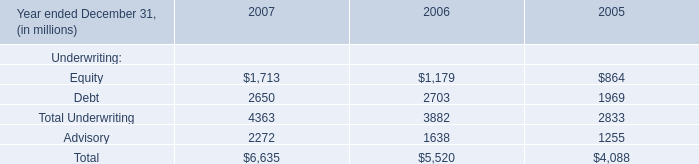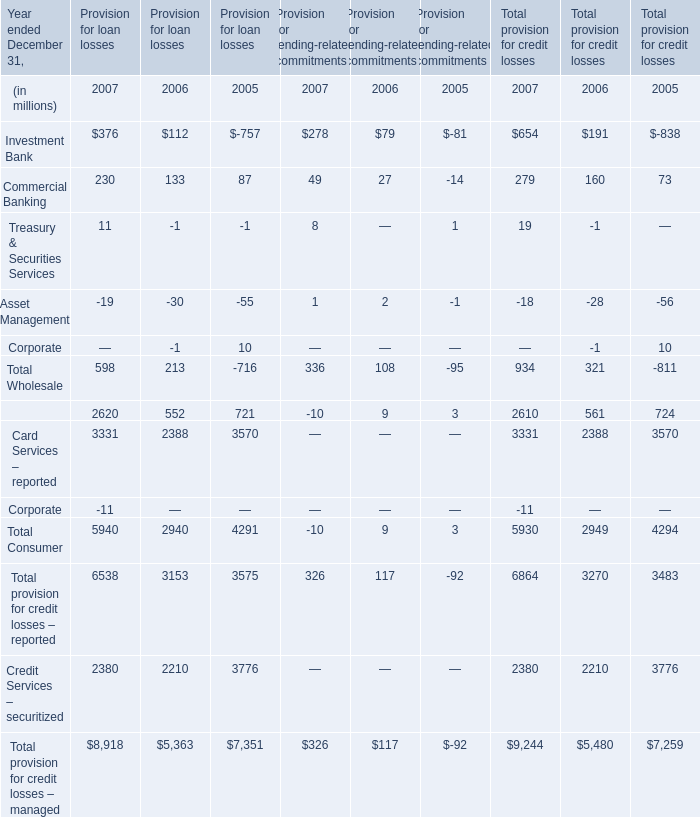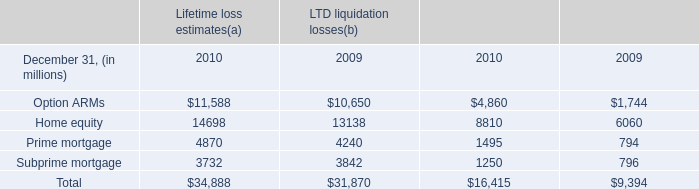What's the sum of Credit Services – securitized of Provision for loan losses 2006, Subprime mortgage of LTD liquidation losses 2010, and Card Services – reported of Provision for loan losses 2005 ? 
Computations: ((2210.0 + 1250.0) + 3570.0)
Answer: 7030.0. 